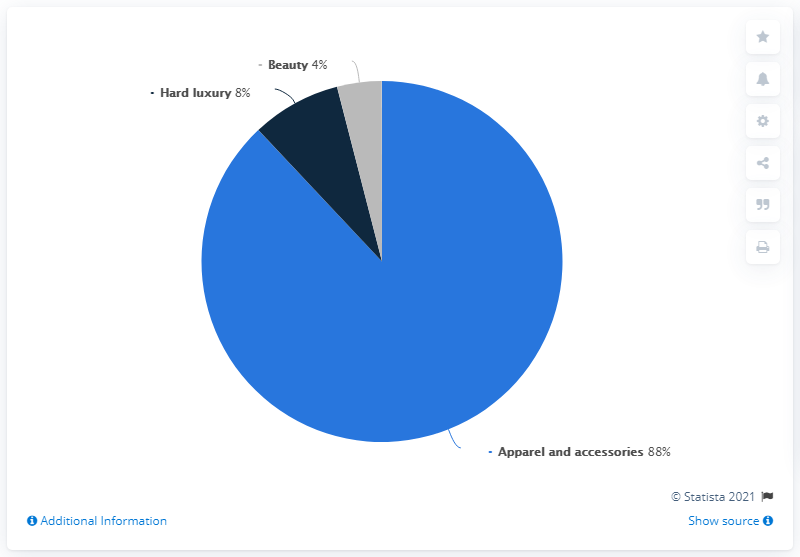Indicate a few pertinent items in this graphic. Beauty has 4%. The difference between the highest and the median values is 80. 